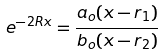Convert formula to latex. <formula><loc_0><loc_0><loc_500><loc_500>e ^ { - 2 R x } = \frac { a _ { o } ( x - r _ { 1 } ) } { b _ { o } ( x - r _ { 2 } ) }</formula> 